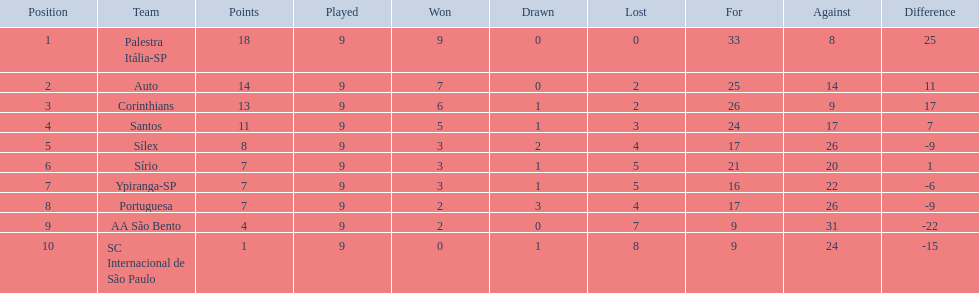During the 1926 football season in brazil, how many teams competed? Palestra Itália-SP, Auto, Corinthians, Santos, Sílex, Sírio, Ypiranga-SP, Portuguesa, AA São Bento, SC Internacional de São Paulo. What was the maximum number of games won by a team that year? 9. Which team ranked first with a total of 9 wins in the 1926 season? Palestra Itália-SP. 